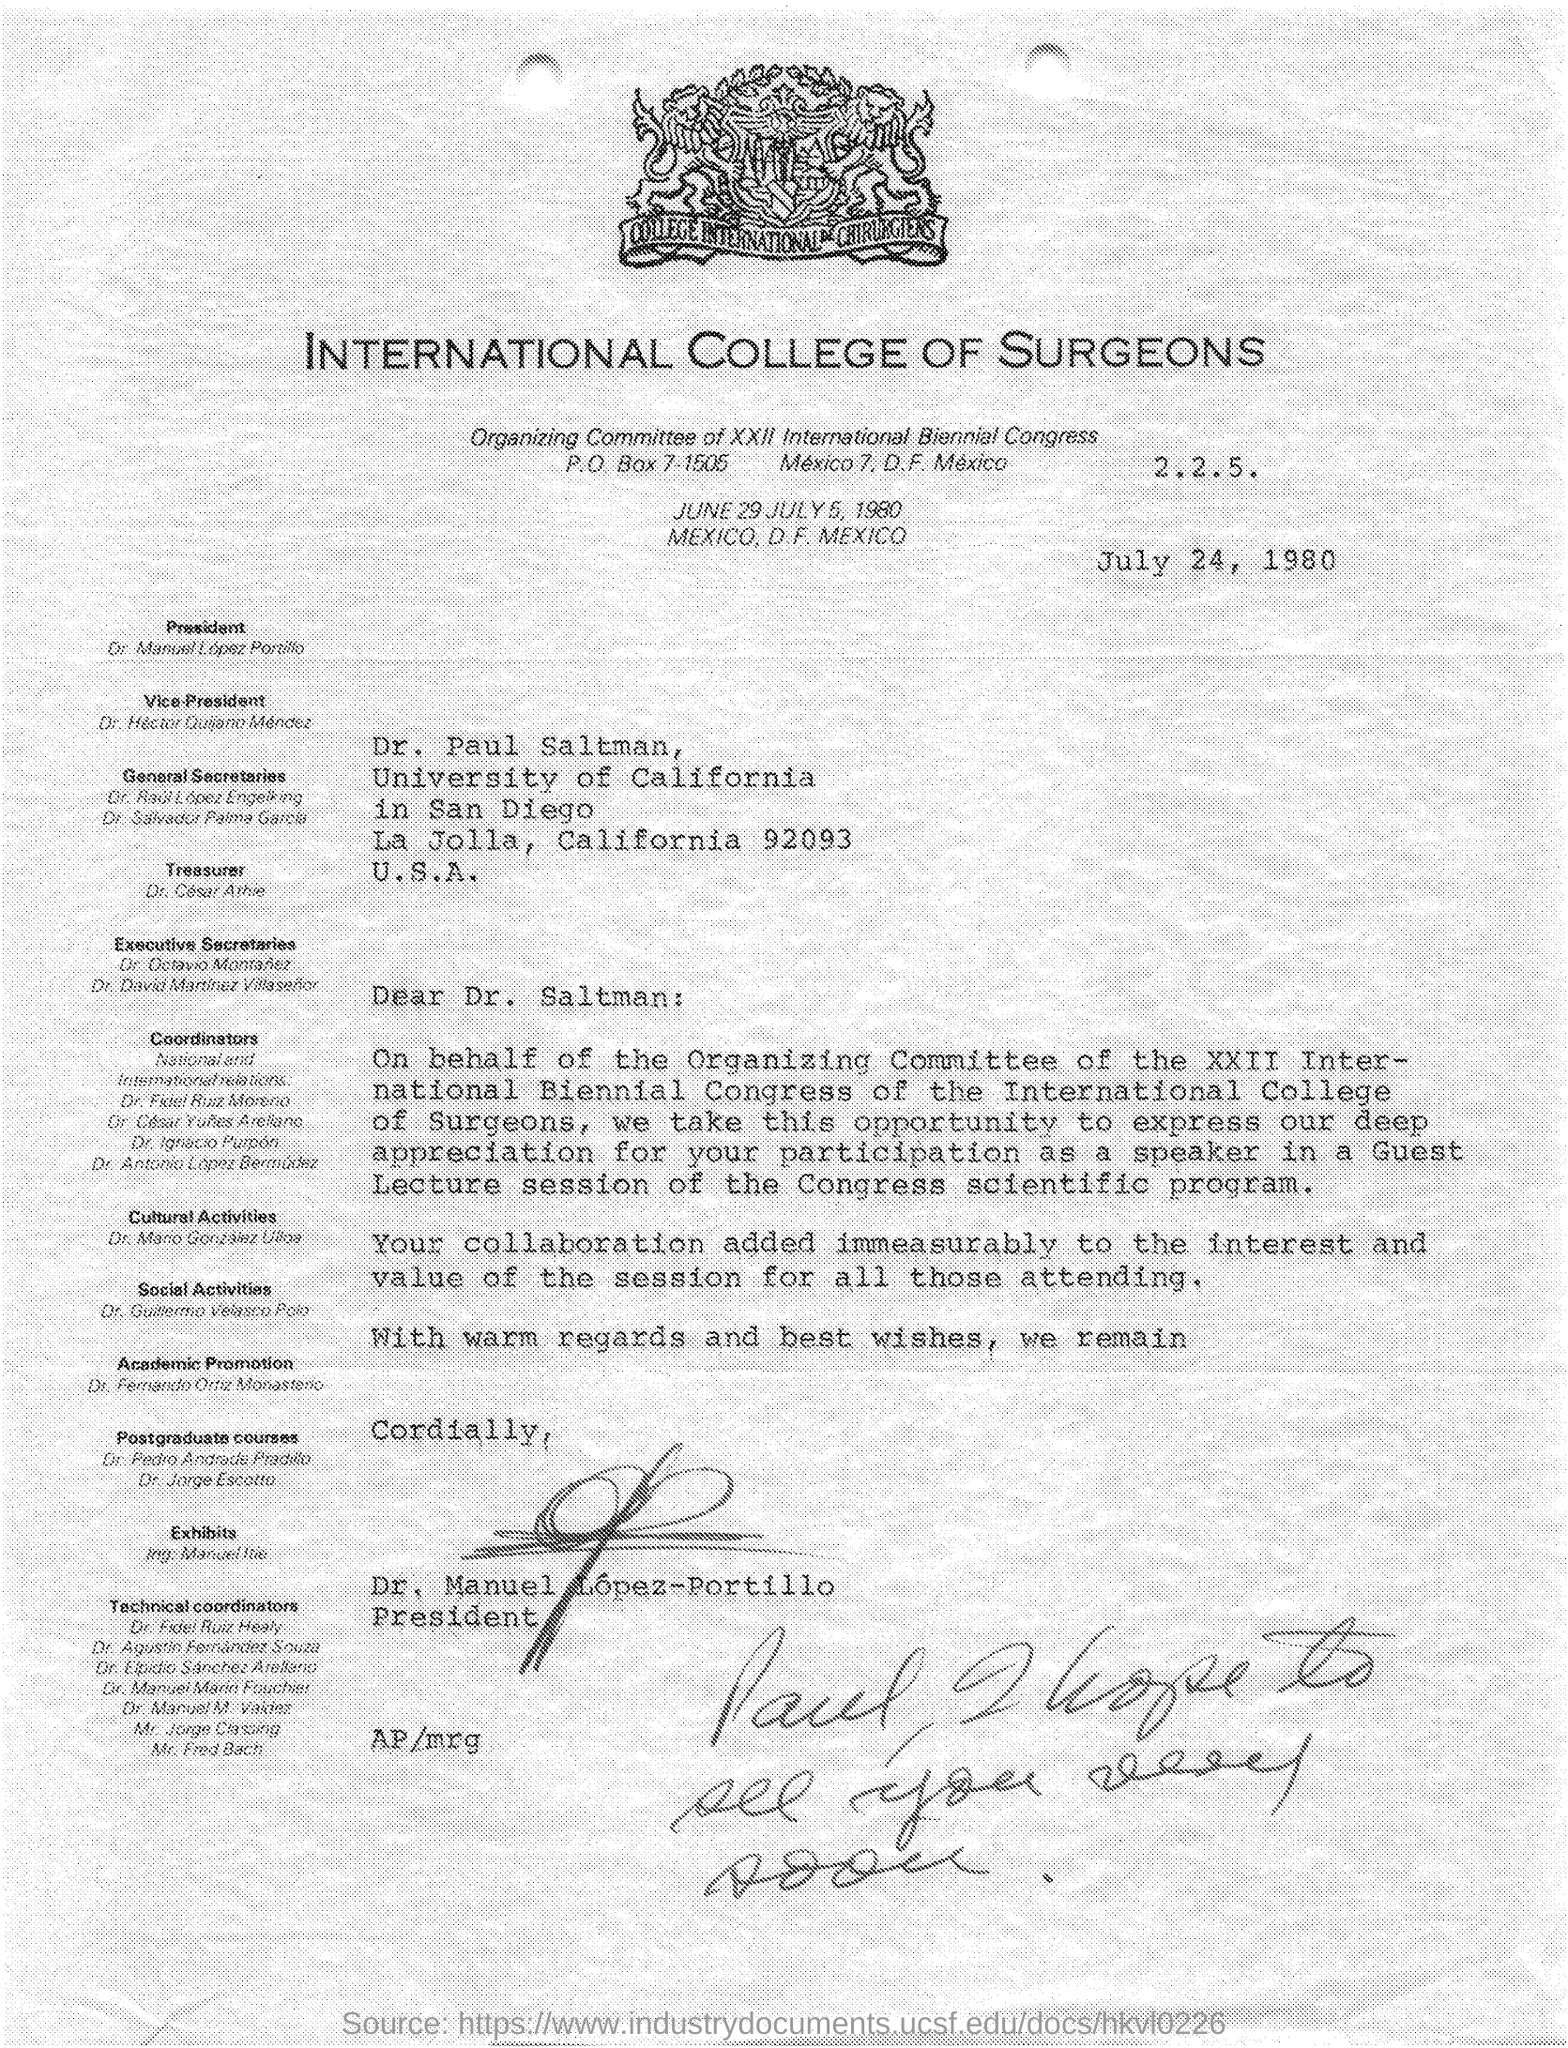List a handful of essential elements in this visual. This letter is dated July 24, 1980. 